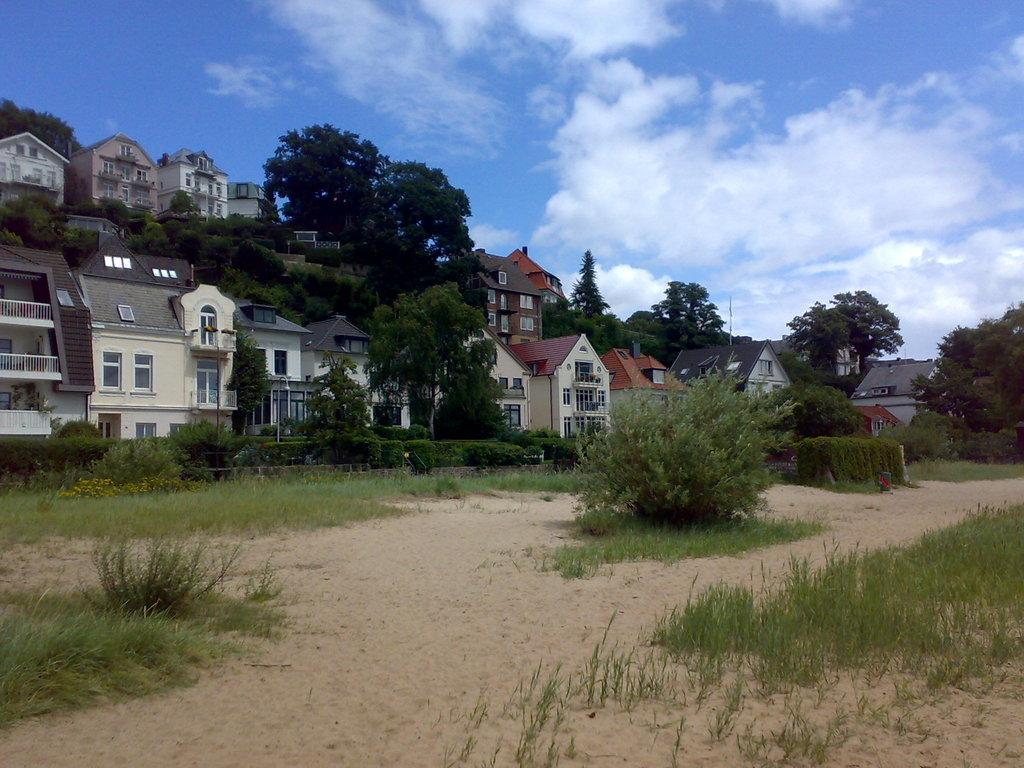What type of structures can be seen in the image? There are many buildings in the image. What part of the buildings can be seen? The windows of the buildings are visible. What type of vegetation is present in the image? There are trees, plants, and grass visible in the image. What type of terrain is present in the image? There is sand visible in the image. What is the condition of the sky in the image? The sky is cloudy in the image. How many houses are coughing in the image? There are no houses present in the image, and houses do not have the ability to cough. Can you tell me how many sneezes can be heard in the image? There are no sounds or sneezes present in the image. 